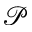<formula> <loc_0><loc_0><loc_500><loc_500>\mathcal { P }</formula> 